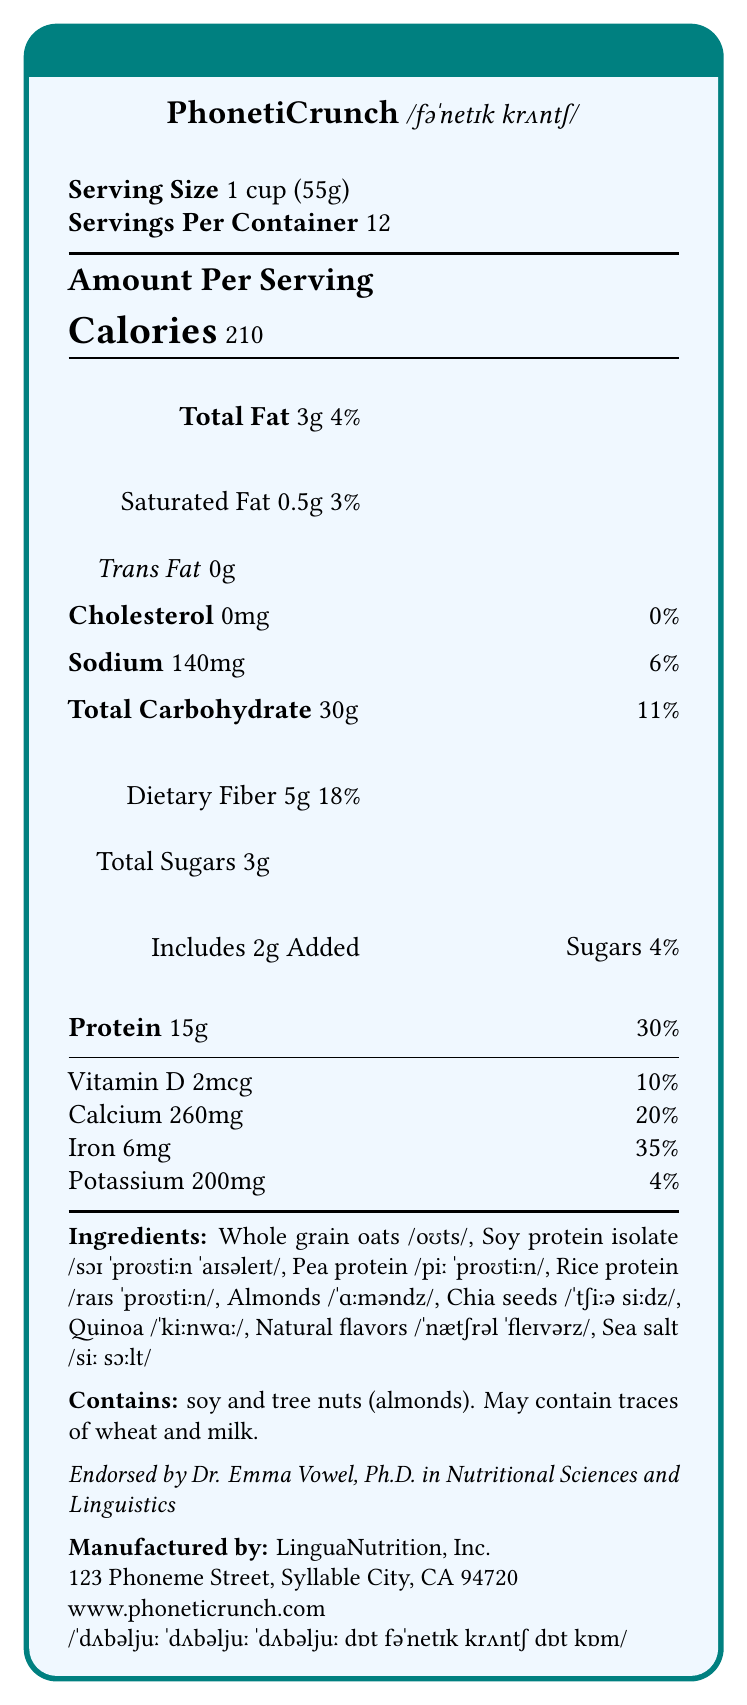what is the serving size of PhonetiCrunch? The serving size is clearly stated at the top of the Nutrition Facts section as "1 cup (55g)."
Answer: 1 cup (55g) how many calories are in one serving of PhonetiCrunch? This information is found under the "Amount Per Serving" section where it states "Calories 210".
Answer: 210 what is the percentage of Daily Value of iron in one serving of PhonetiCrunch? The percentage of Daily Value of iron is listed in the vitamins and minerals section as "Iron 6mg - 35%".
Answer: 35% how much protein is in one serving of PhonetiCrunch? This is found under the "Amount Per Serving" section, specifically where it lists nutrients, stating "Protein 15g - 30%."
Answer: 15g what allergens are contained in PhonetiCrunch? This information is provided under the "Contains" section which mentions soy and tree nuts (almonds).
Answer: Soy and tree nuts (almonds) what is the phonetic pronunciation of "PhonetiCrunch"? The phonetic pronunciation is stated next to the product name at the top of the document.
Answer: /fəˈnetɪk krʌntʃ/ what are the main sources of protein in PhonetiCrunch? A. Whole grain oats, Soy protein isolate B. Soy protein isolate, Pea protein, Rice protein, Almonds C. Chia seeds, Quinoa, Sea salt D. Natural flavors, Sea salt The ingredients list mentions that the primary protein sources are soy protein isolate, pea protein, rice protein, and almonds.
Answer: B how many grams of dietary fiber does one serving of PhonetiCrunch contain? A. 2g B. 5g C. 7g D. 10g The dietary fiber content is listed under Total Carbohydrate as "Dietary Fiber 5g - 18%."
Answer: B is there any trans fat in PhonetiCrunch? The document clearly states "Trans Fat 0g" indicating there is no trans fat.
Answer: No does PhonetiCrunch contain any added sugars? The document lists "Includes 2g Added Sugars" under the Total Sugars section.
Answer: Yes who endorses PhonetiCrunch? This endorsement is mentioned towards the bottom, stating "Endorsed by Dr. Emma Vowel, Ph.D. in Nutritional Sciences and Linguistics."
Answer: Dr. Emma Vowel, Ph.D. in Nutritional Sciences and Linguistics how many servings are there in one container of PhonetiCrunch? This information can be found at the top where it states "Servings Per Container 12."
Answer: 12 how much calcium is in one serving of PhonetiCrunch? The calcium amount per serving is listed in the vitamins and minerals section as "Calcium 260mg - 20%."
Answer: 260mg summarize the main features and item details observed in the PhonetiCrunch Nutrition Facts Label. This summary includes details about serving size, number of servings, nutritional content, ingredient list, allergen information, endorsement, and manufacturer details.
Answer: The Nutrition Facts Label for PhonetiCrunch highlights its nutritional content for a high-protein breakfast cereal. Each serving size is 1 cup (55g), and there are 12 servings per container. It contains 210 calories, 15g of protein, and provides various vitamins and minerals, including significant amounts of iron and calcium. The ingredient list includes whole grains and plant-based proteins with phonetic transcriptions. It also contains soy and tree nuts (almonds) and may contain traces of wheat and milk. The product is endorsed by Dr. Emma Vowel and is manufactured by LinguaNutrition, Inc. what are the stress patterns in the packaging of PhonetiCrunch? The document mentions that stress patterns are highlighted on packaging but does not provide specific details.
Answer: Not enough information 